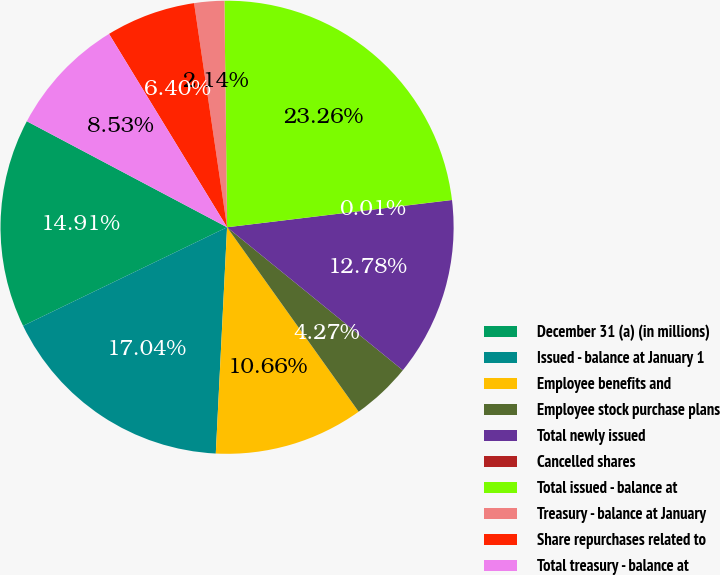Convert chart. <chart><loc_0><loc_0><loc_500><loc_500><pie_chart><fcel>December 31 (a) (in millions)<fcel>Issued - balance at January 1<fcel>Employee benefits and<fcel>Employee stock purchase plans<fcel>Total newly issued<fcel>Cancelled shares<fcel>Total issued - balance at<fcel>Treasury - balance at January<fcel>Share repurchases related to<fcel>Total treasury - balance at<nl><fcel>14.92%<fcel>17.05%<fcel>10.66%<fcel>4.27%<fcel>12.79%<fcel>0.01%<fcel>23.27%<fcel>2.14%<fcel>6.4%<fcel>8.53%<nl></chart> 